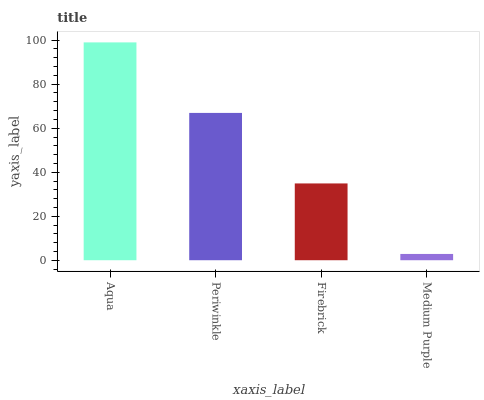Is Medium Purple the minimum?
Answer yes or no. Yes. Is Aqua the maximum?
Answer yes or no. Yes. Is Periwinkle the minimum?
Answer yes or no. No. Is Periwinkle the maximum?
Answer yes or no. No. Is Aqua greater than Periwinkle?
Answer yes or no. Yes. Is Periwinkle less than Aqua?
Answer yes or no. Yes. Is Periwinkle greater than Aqua?
Answer yes or no. No. Is Aqua less than Periwinkle?
Answer yes or no. No. Is Periwinkle the high median?
Answer yes or no. Yes. Is Firebrick the low median?
Answer yes or no. Yes. Is Medium Purple the high median?
Answer yes or no. No. Is Medium Purple the low median?
Answer yes or no. No. 